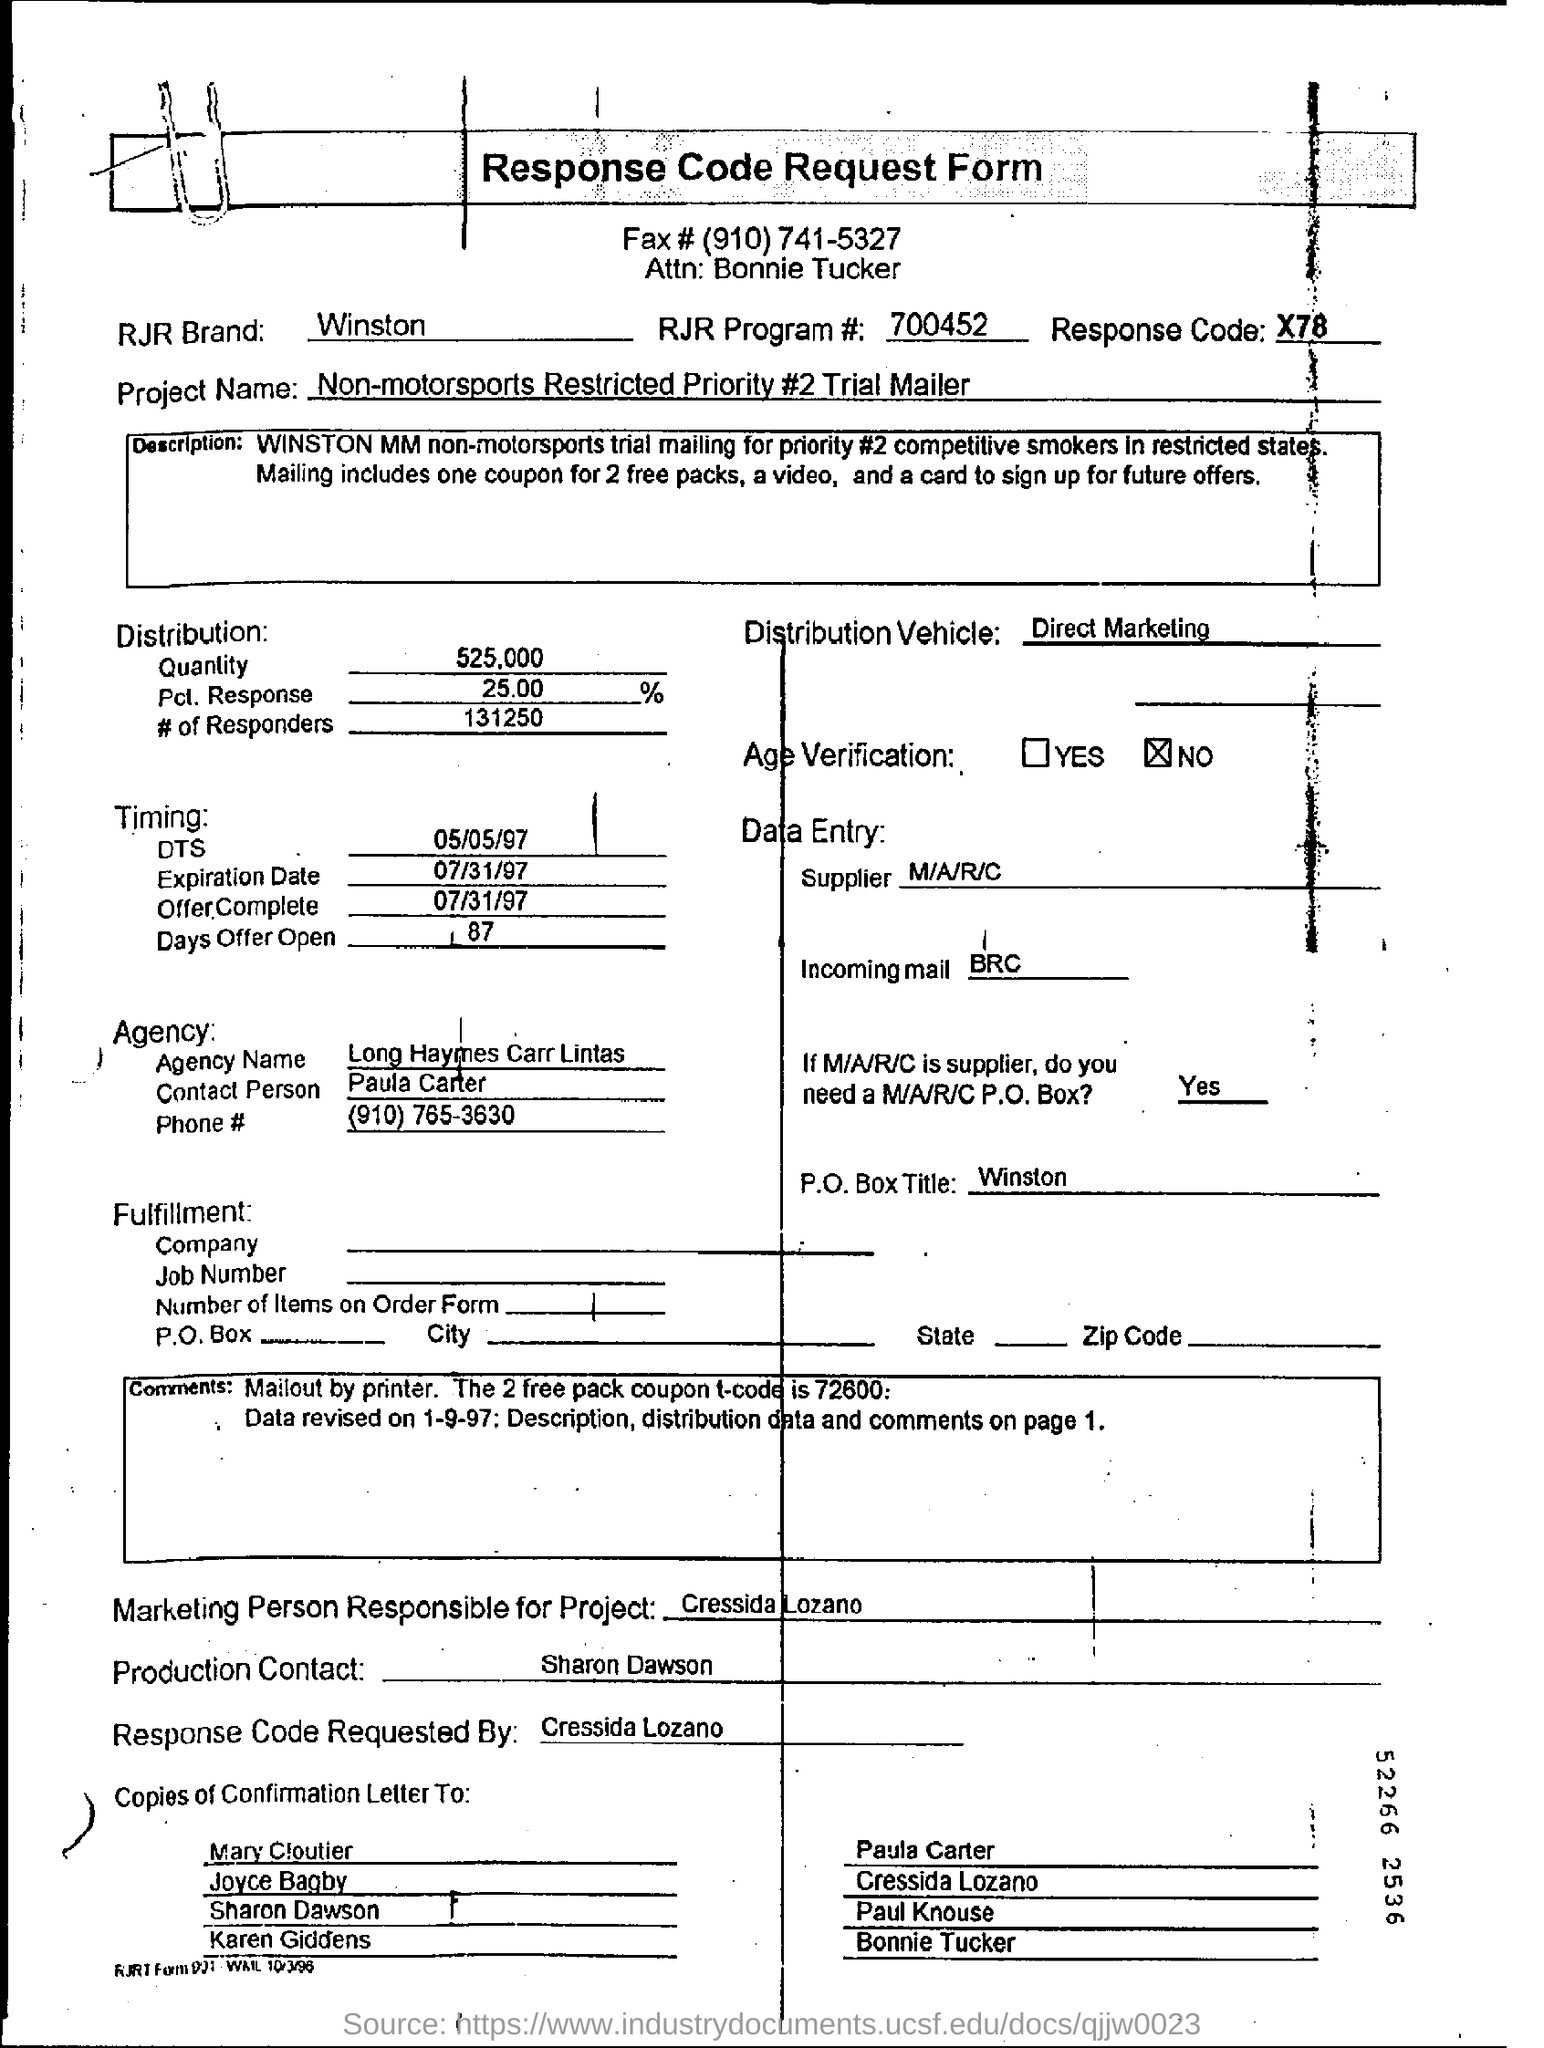Indicate a few pertinent items in this graphic. The RJR Brand name is Winston. The agency named Long Haymes Carr Lintas is mentioned. 